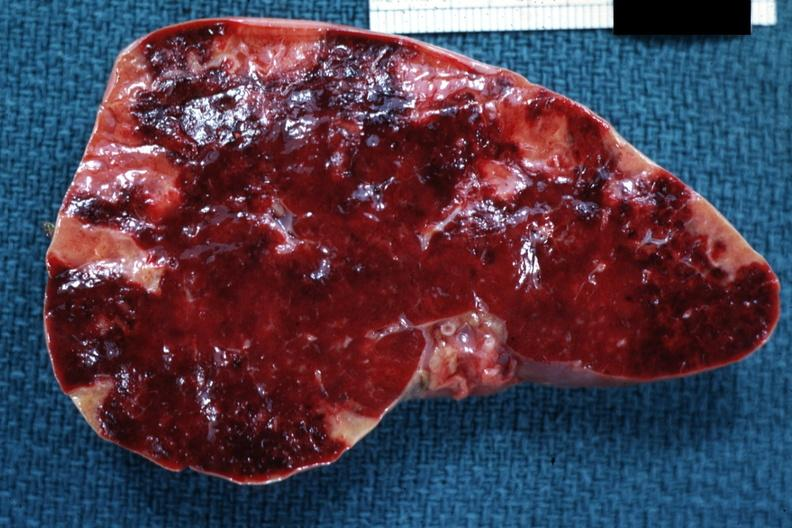does this image show cut surface of spleen with multiple recent infarcts very good example?
Answer the question using a single word or phrase. Yes 